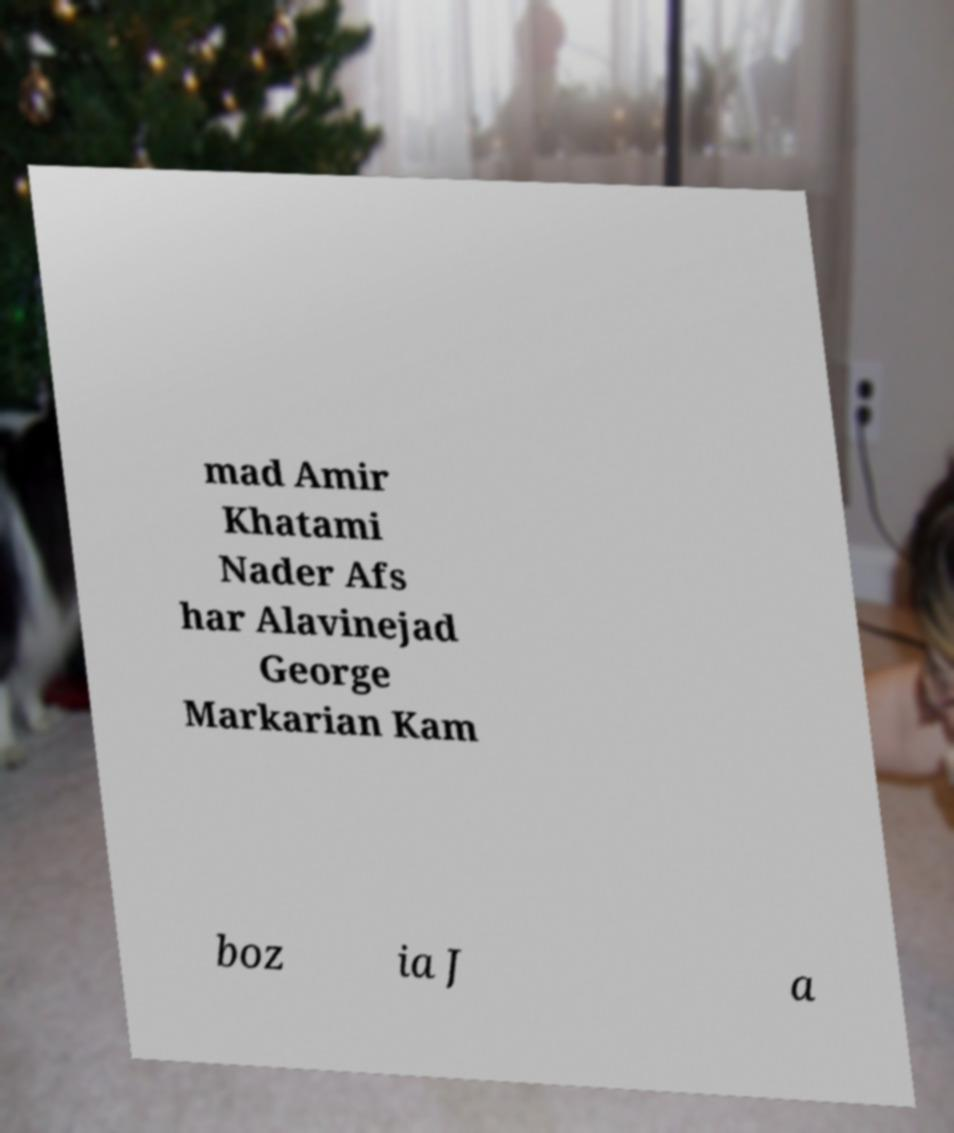I need the written content from this picture converted into text. Can you do that? mad Amir Khatami Nader Afs har Alavinejad George Markarian Kam boz ia J a 